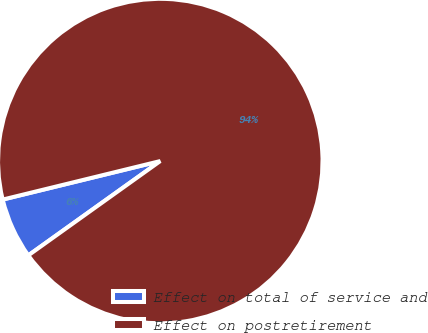Convert chart. <chart><loc_0><loc_0><loc_500><loc_500><pie_chart><fcel>Effect on total of service and<fcel>Effect on postretirement<nl><fcel>6.06%<fcel>93.94%<nl></chart> 